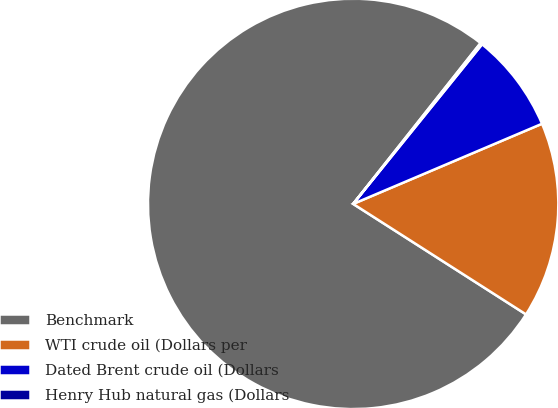Convert chart to OTSL. <chart><loc_0><loc_0><loc_500><loc_500><pie_chart><fcel>Benchmark<fcel>WTI crude oil (Dollars per<fcel>Dated Brent crude oil (Dollars<fcel>Henry Hub natural gas (Dollars<nl><fcel>76.61%<fcel>15.44%<fcel>7.8%<fcel>0.15%<nl></chart> 